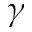Convert formula to latex. <formula><loc_0><loc_0><loc_500><loc_500>\gamma</formula> 